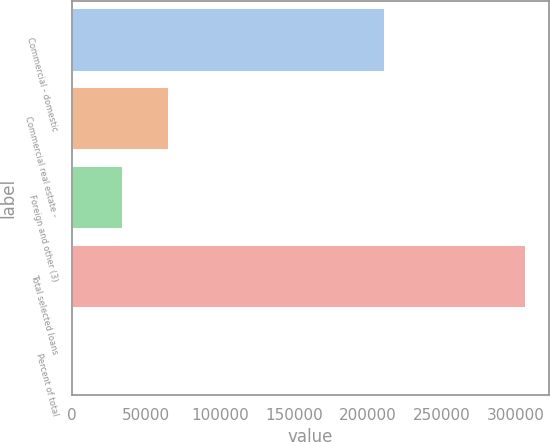<chart> <loc_0><loc_0><loc_500><loc_500><bar_chart><fcel>Commercial - domestic<fcel>Commercial real estate -<fcel>Foreign and other (3)<fcel>Total selected loans<fcel>Percent of total<nl><fcel>211792<fcel>65143.3<fcel>34473<fcel>306803<fcel>100<nl></chart> 